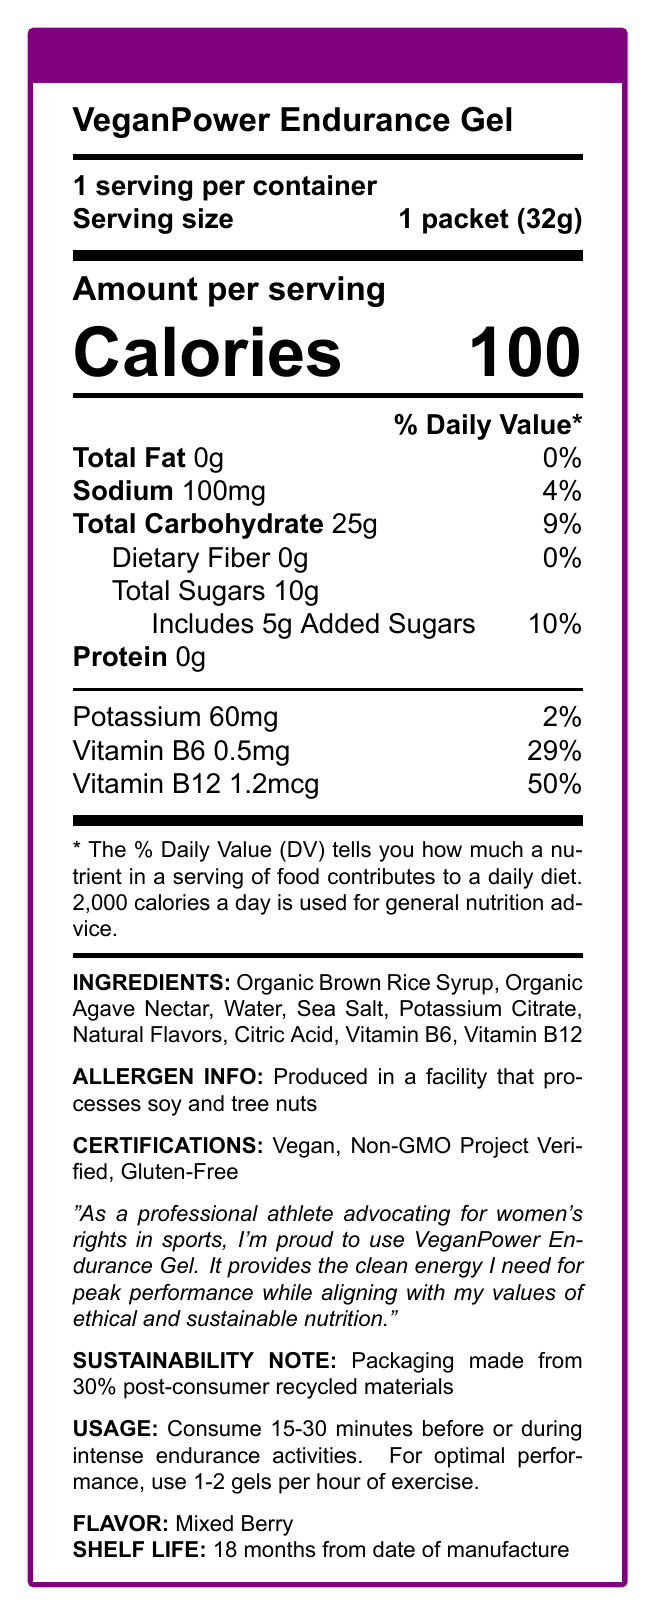what is the serving size for VeganPower Endurance Gel? The serving size is clearly indicated at the beginning of the document under the nutrition facts section: "Serving size: 1 packet (32g)."
Answer: 1 packet (32g) how many calories are in one serving of the VeganPower Endurance Gel? The amount of calories per serving is found under the "Amount per serving" section: "Calories 100."
Answer: 100 what is the amount of total carbohydrates in one serving? The total carbohydrates in one serving is listed under the "Amount per serving" section: "Total Carbohydrate 25g."
Answer: 25g how much sodium does one packet contain, and what percentage of the daily value does this represent? The sodium content is listed as "Sodium 100mg 4%" under the "Amount per serving" section. The percentage of the daily value is also provided.
Answer: 100mg, 4% does the product contain any dietary fiber? The document specifies: "Dietary Fiber 0g 0%," indicating that there is no dietary fiber in the product.
Answer: No what are the main ingredients of the VeganPower Endurance Gel? The ingredients are listed in the document under the "INGREDIENTS" section.
Answer: Organic Brown Rice Syrup, Organic Agave Nectar, Water, Sea Salt, Potassium Citrate, Natural Flavors, Citric Acid, Vitamin B6, Vitamin B12 what certifications does the VeganPower Endurance Gel have? A. Vegan B. Organic C. Gluten-Free D. Non-GMO Project Verified The certifications listed in the document are "Vegan," "Non-GMO Project Verified," and "Gluten-Free." "Organic" is not one of the mentioned certifications.
Answer: A, C, D which vitamin is present in the highest daily value percentage in the VeganPower Endurance Gel? A. Vitamin B6 B. Vitamin B12 C. Vitamin D D. Vitamin C The document lists Vitamin B12 with a daily value percentage of 50%, which is higher than Vitamin B6 at 29%. There is no mention of Vitamin D or Vitamin C.
Answer: B is the VeganPower Endurance Gel made from completely recycled materials? The document states: "Packaging made from 30% post-consumer recycled materials," indicating that the gel's packaging is only partially made from recycled materials.
Answer: No how should you consume the VeganPower Endurance Gel for optimal performance during exercise? The usage instructions are clearly mentioned in the document under the "USAGE" section.
Answer: Consume 15-30 minutes before or during intense endurance activities. Use 1-2 gels per hour of exercise. what is the product's flavor? The flavor is specified in the document as "Mixed Berry" under the "FLAVOR" section.
Answer: Mixed Berry what is the shelf life of the VeganPower Endurance Gel? The document under "SHELF LIFE" states that the shelf life is "18 months from date of manufacture."
Answer: 18 months from date of manufacture summarize the main point of the VeganPower Endurance Gel document. The document provides detailed information about the nutritional content, ingredients, certifications, usage instructions, flavor, shelf life, and a note on the sustainable packaging of the VeganPower Endurance Gel, alongside testimonials and allergen information.
Answer: VeganPower Endurance Gel is a vegan-certified, non-GMO, and gluten-free energy gel designed for endurance training, providing 100 calories per serving with added vitamins B6 and B12. It's made with organic ingredients and packaged in partially recycled materials, aligning with the values of ethical and sustainable nutrition. It’s suitable to consume 15-30 minutes before or during intense activities. The product is mixed berry flavored. how much protein does one packet of VeganPower Endurance Gel contain? The document lists the protein content as "Protein 0g" under the "Amount per serving" section.
Answer: 0g what kind of facility is the VeganPower Endurance Gel produced in? The allergen information provided in the document states: "Produced in a facility that processes soy and tree nuts."
Answer: Produced in a facility that processes soy and tree nuts can you determine the price of VeganPower Endurance Gel from this document? The document does not provide any information on the price of the VeganPower Endurance Gel.
Answer: Not enough information 